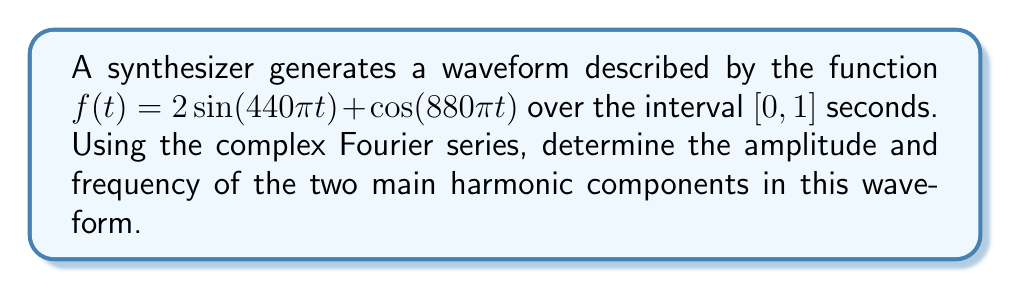Give your solution to this math problem. 1) The complex Fourier series for a periodic function $f(t)$ with period $T$ is given by:

   $f(t) = \sum_{n=-\infty}^{\infty} c_n e^{i2\pi nt/T}$

   where $c_n = \frac{1}{T} \int_0^T f(t) e^{-i2\pi nt/T} dt$

2) In our case, $T = 1$ second. We need to find $c_n$ for $n = \pm 220$ and $n = \pm 440$, as these correspond to the frequencies in our waveform.

3) For $n = 220$:
   $c_{220} = \frac{1}{1} \int_0^1 (2\sin(440\pi t) + \cos(880\pi t)) e^{-i440\pi t} dt$
   
   Using Euler's formula, $\sin(x) = \frac{e^{ix} - e^{-ix}}{2i}$ and $\cos(x) = \frac{e^{ix} + e^{-ix}}{2}$:
   
   $c_{220} = \frac{1}{1} \int_0^1 (2\frac{e^{i440\pi t} - e^{-i440\pi t}}{2i} + \frac{e^{i880\pi t} + e^{-i880\pi t}}{2}) e^{-i440\pi t} dt$

   $c_{220} = \frac{1}{i} \int_0^1 (e^{i440\pi t} - e^{-i440\pi t}) e^{-i440\pi t} dt + \frac{1}{2} \int_0^1 (e^{i880\pi t} + e^{-i880\pi t}) e^{-i440\pi t} dt$

   $c_{220} = \frac{1}{i} \int_0^1 (1 - e^{-i880\pi t}) dt + \frac{1}{2} \int_0^1 (e^{i440\pi t} + e^{-i880\pi t}) dt$

   $c_{220} = \frac{1}{i} [t - \frac{e^{-i880\pi t}}{-i880\pi}]_0^1 + \frac{1}{2} [\frac{e^{i440\pi t}}{i440\pi} - \frac{e^{-i880\pi t}}{-i880\pi}]_0^1$

   $c_{220} = \frac{1}{i} (1 - 0 + 0 - 0) + \frac{1}{2} (0 - 0 - 0 + 0) = -i$

4) Similarly, for $n = -220$, we get $c_{-220} = i$

5) For $n = 440$:
   $c_{440} = \frac{1}{1} \int_0^1 (2\sin(440\pi t) + \cos(880\pi t)) e^{-i880\pi t} dt$
   
   Following similar steps as above:
   
   $c_{440} = \frac{1}{2}$

6) Similarly, for $n = -440$, we get $c_{-440} = \frac{1}{2}$

7) The amplitude of each harmonic component is given by $2|c_n|$:
   For $n = \pm 220$: $2|c_{220}| = 2|c_{-220}| = 2|-i| = 2$
   For $n = \pm 440$: $2|c_{440}| = 2|c_{-440}| = 2|\frac{1}{2}| = 1$

8) The frequencies are 220 Hz and 440 Hz, corresponding to $n = 220$ and $n = 440$ respectively.
Answer: Two main harmonic components: (2, 220 Hz) and (1, 440 Hz) 